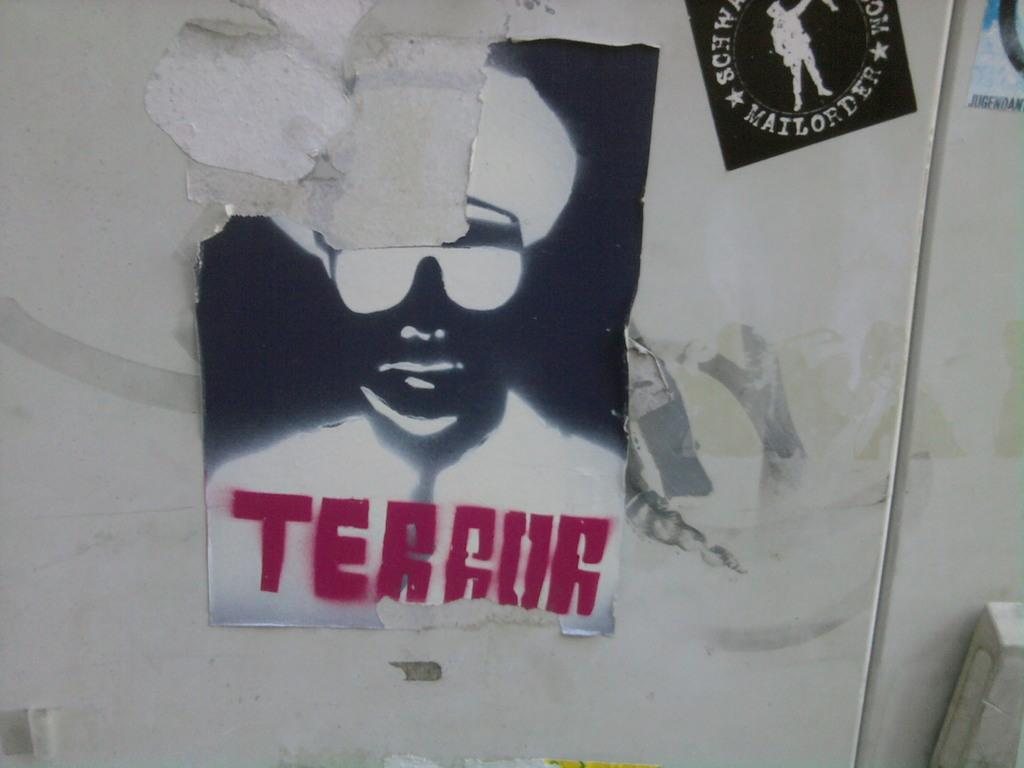What is the main subject of the image in the picture? There is an image in the shape of a man in the picture. What can be seen written on a wall in the image? The text "terror" is written in red color on a wall. What is the color and location of the sticker in the image? There is a sticker in black color at the top of the image. What type of treatment is being administered to the man in the image? There is no treatment being administered to the man in the image; it is a static image. What is the zinc content of the sticker in the image? There is no information about the zinc content of the sticker in the image, as it is a black sticker. 